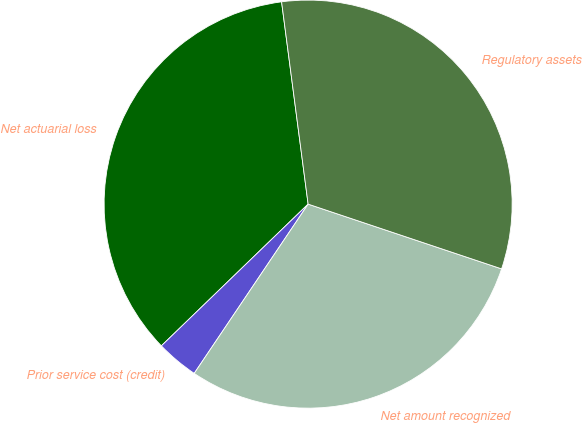Convert chart. <chart><loc_0><loc_0><loc_500><loc_500><pie_chart><fcel>Net actuarial loss<fcel>Prior service cost (credit)<fcel>Net amount recognized<fcel>Regulatory assets<nl><fcel>35.15%<fcel>3.35%<fcel>29.29%<fcel>32.22%<nl></chart> 